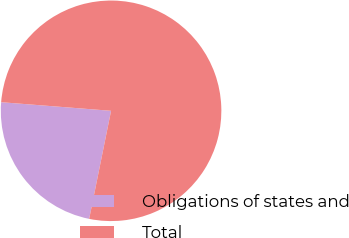Convert chart to OTSL. <chart><loc_0><loc_0><loc_500><loc_500><pie_chart><fcel>Obligations of states and<fcel>Total<nl><fcel>23.06%<fcel>76.94%<nl></chart> 